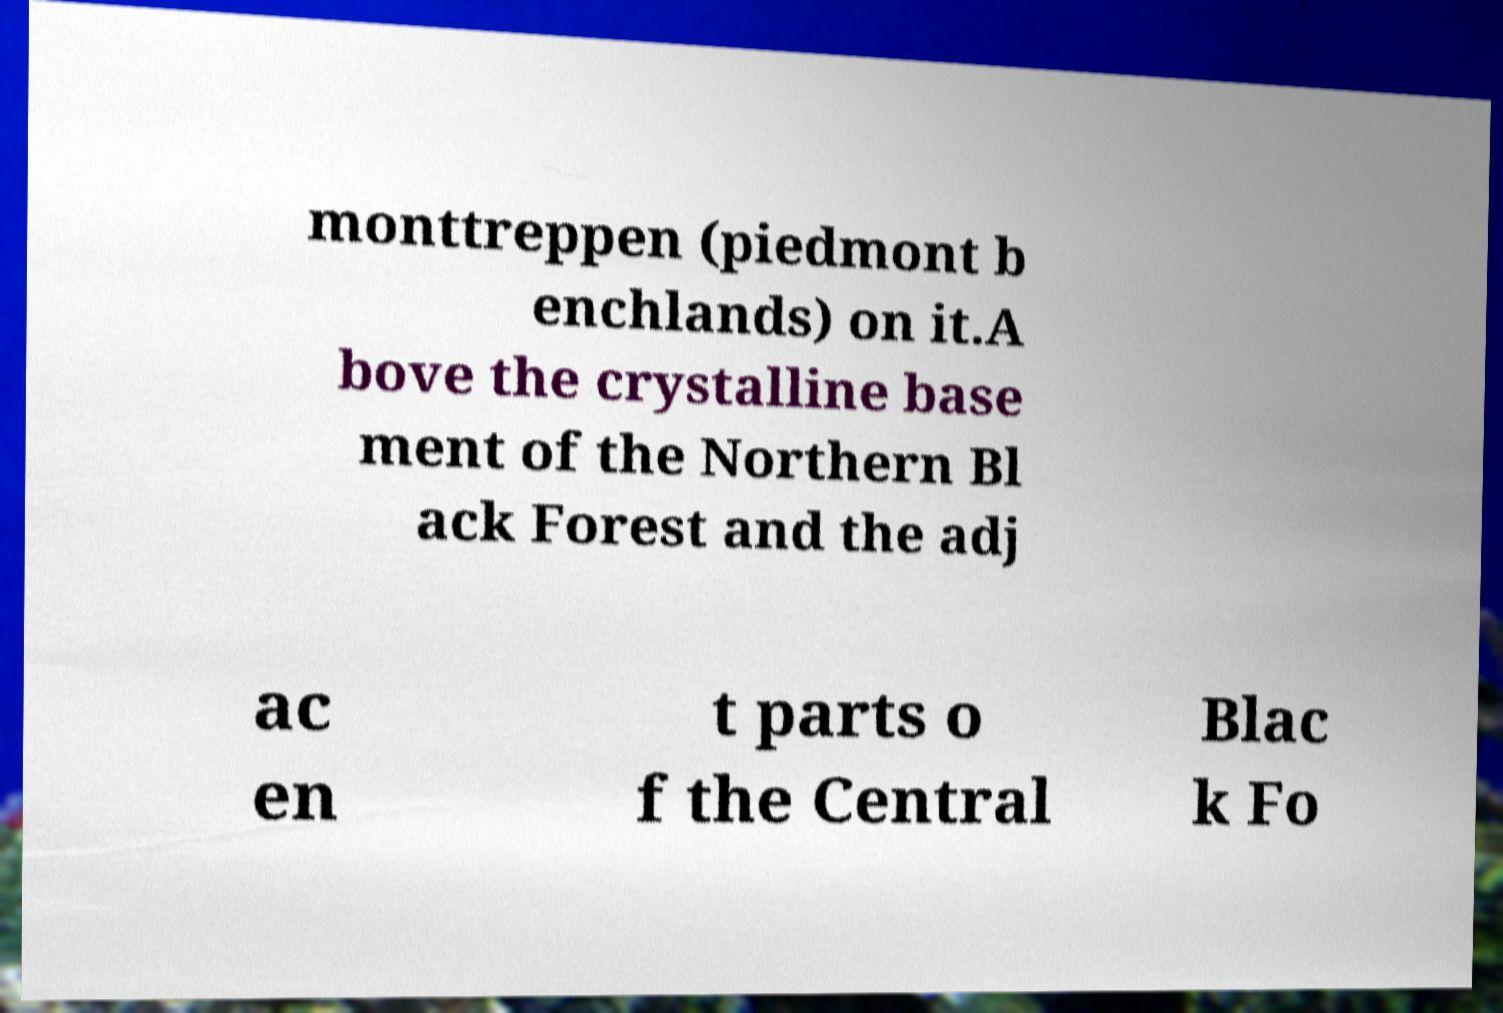Can you read and provide the text displayed in the image?This photo seems to have some interesting text. Can you extract and type it out for me? monttreppen (piedmont b enchlands) on it.A bove the crystalline base ment of the Northern Bl ack Forest and the adj ac en t parts o f the Central Blac k Fo 